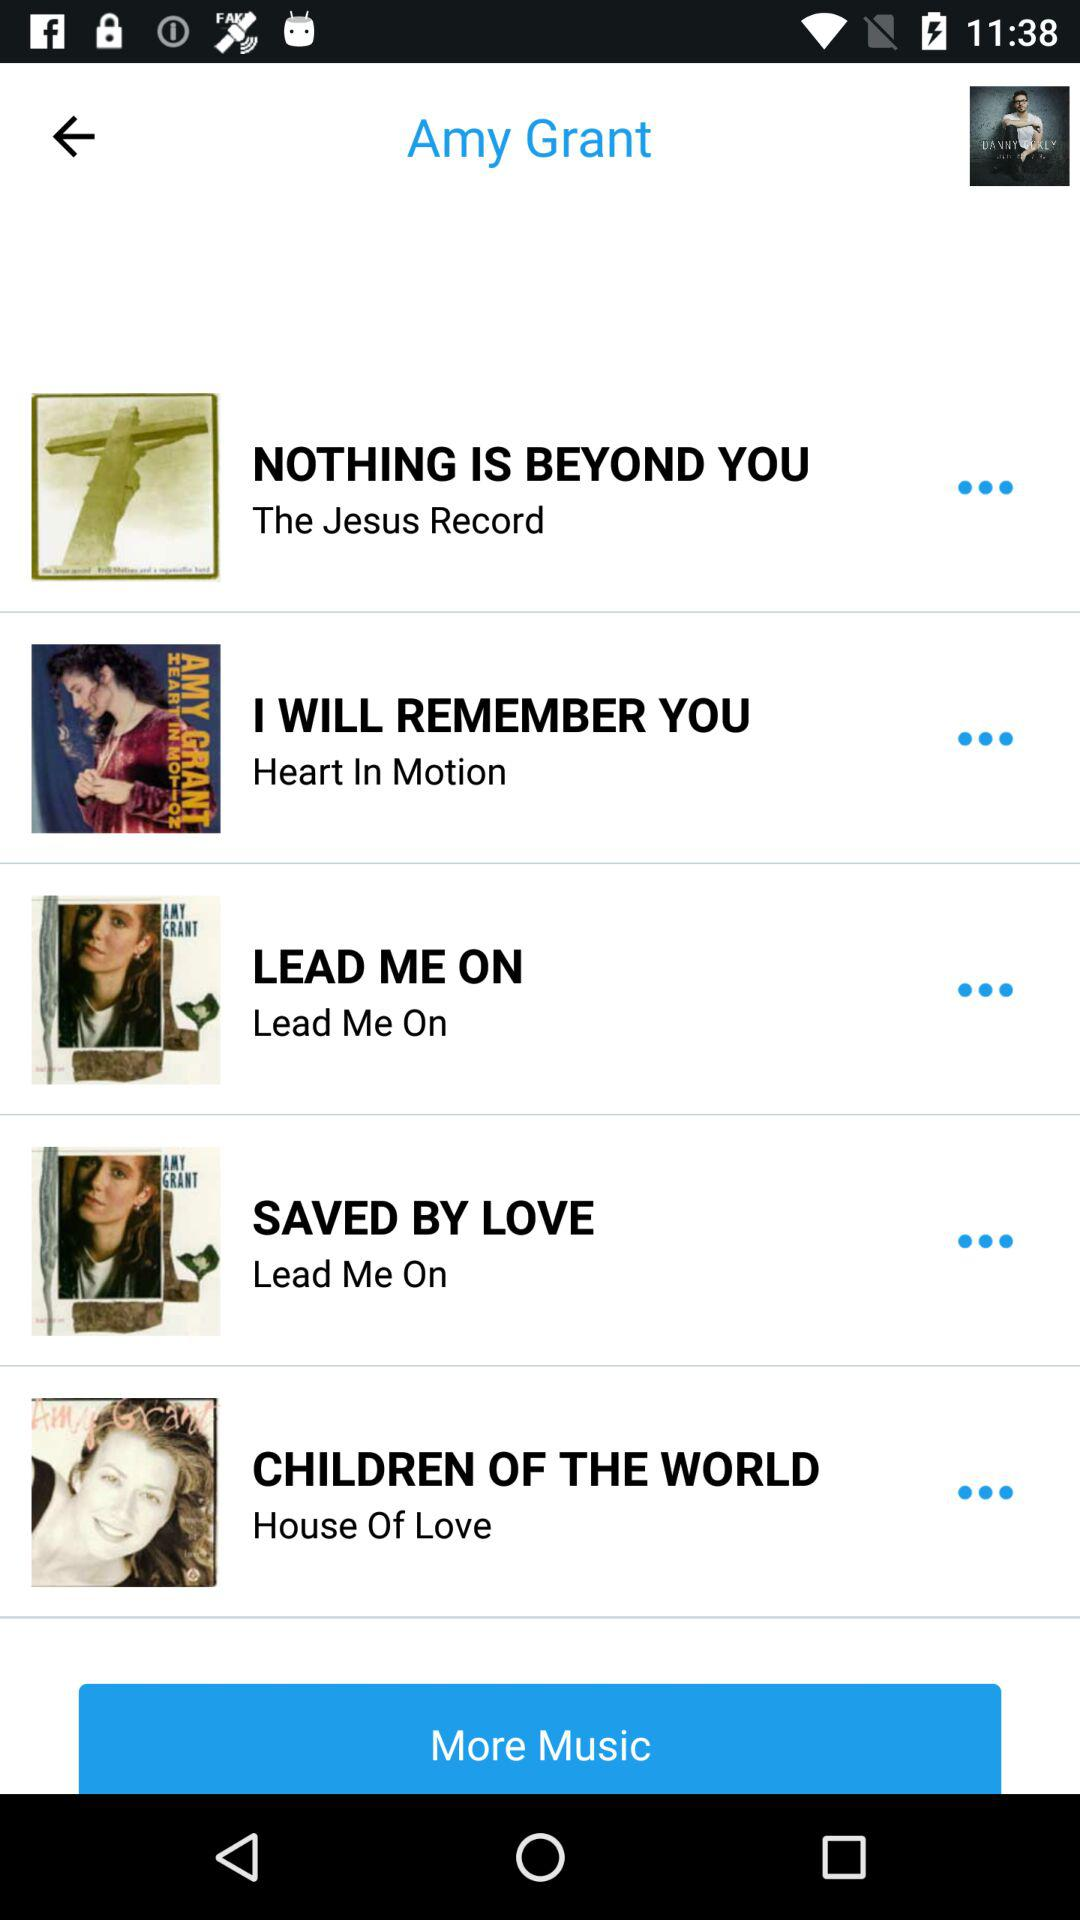Who produced "SAVED BY LOVE"?
When the provided information is insufficient, respond with <no answer>. <no answer> 